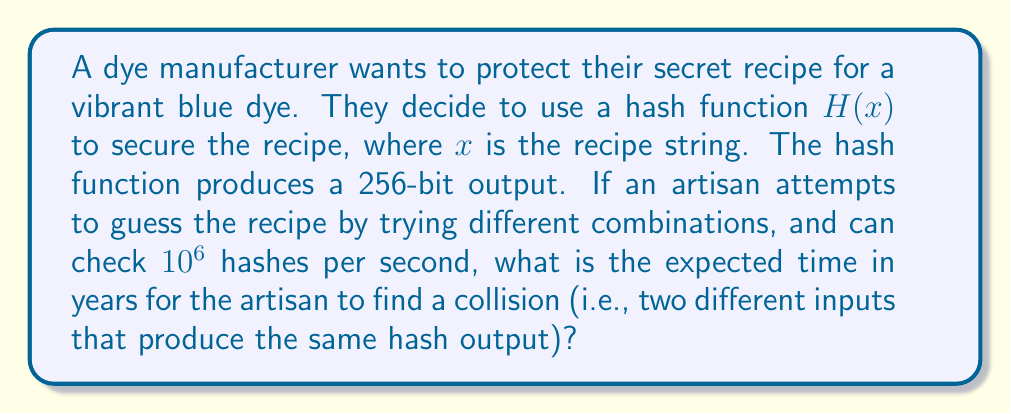Provide a solution to this math problem. To solve this problem, we need to use the birthday attack principle and calculate the time required to find a collision in the hash function.

Step 1: Calculate the number of possible hash outputs.
Number of possible outputs = $2^{256}$ (since it's a 256-bit hash)

Step 2: Calculate the number of hash attempts needed for a 50% chance of collision.
Using the birthday attack principle, we need approximately $\sqrt{2^{256}} = 2^{128}$ attempts.

Step 3: Calculate the time required to make these attempts.
Time in seconds = $\frac{2^{128}}{10^6}$ (since the artisan can check $10^6$ hashes per second)

Step 4: Convert seconds to years.
Seconds in a year = $365 \times 24 \times 60 \times 60 = 31,536,000$

Years = $\frac{2^{128}}{10^6 \times 31,536,000}$

Step 5: Simplify the calculation.
Years = $\frac{2^{128}}{10^6 \times 31,536,000} \approx 1.0769 \times 10^{31}$

Therefore, it would take approximately $1.0769 \times 10^{31}$ years to have a 50% chance of finding a collision.
Answer: $1.0769 \times 10^{31}$ years 